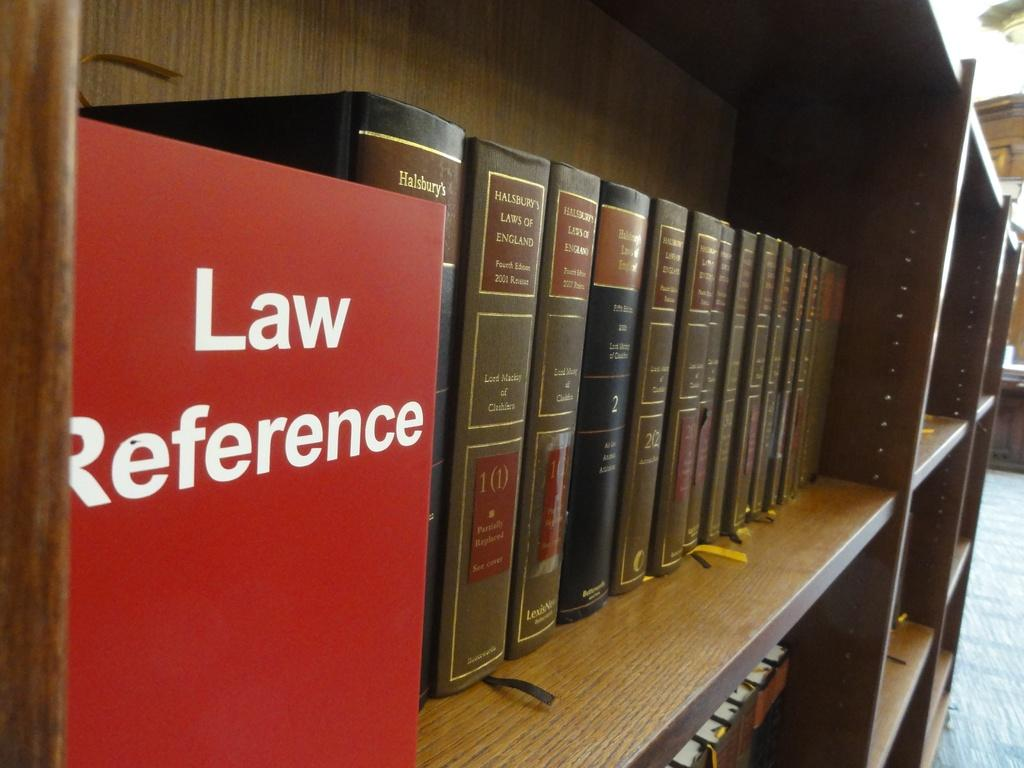<image>
Summarize the visual content of the image. a line of law reference books on a shelf in a library 